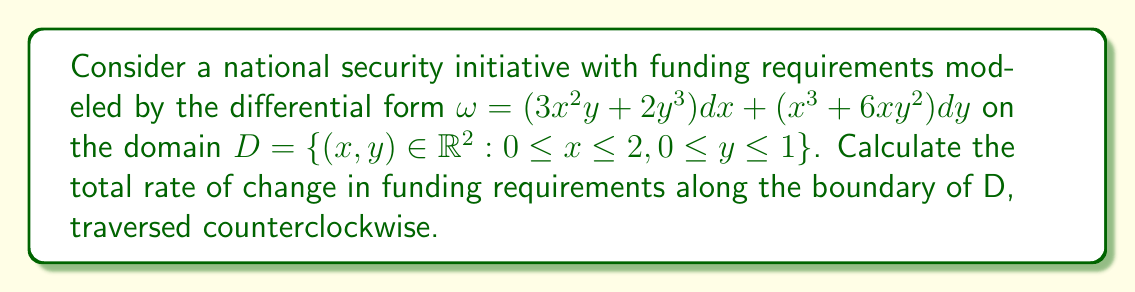Can you solve this math problem? To solve this problem, we'll use Stokes' theorem, which relates the line integral of a differential form along a closed curve to the surface integral of its exterior derivative over the region bounded by the curve.

Step 1: Calculate the exterior derivative of $\omega$
$$d\omega = \left(\frac{\partial}{\partial y}(3x^2y + 2y^3) - \frac{\partial}{\partial x}(x^3 + 6xy^2)\right)dx \wedge dy$$
$$d\omega = (3x^2 + 6y^2 - 3x^2 - 12xy)dx \wedge dy = (6y^2 - 12xy)dx \wedge dy$$

Step 2: Integrate $d\omega$ over the region D
$$\iint_D d\omega = \int_0^2 \int_0^1 (6y^2 - 12xy) dy dx$$

Step 3: Evaluate the double integral
$$\iint_D d\omega = \int_0^2 \left[2y^3 - 6xy^2\right]_0^1 dx = \int_0^2 (2 - 6x) dx = [2x - 3x^2]_0^2 = 4 - 12 = -8$$

Step 4: Apply Stokes' theorem
The line integral of $\omega$ along the boundary of D, traversed counterclockwise, is equal to the surface integral of $d\omega$ over D:

$$\oint_{\partial D} \omega = \iint_D d\omega = -8$$

Therefore, the total rate of change in funding requirements along the boundary of D is -8 (in appropriate units of currency per unit time).
Answer: -8 